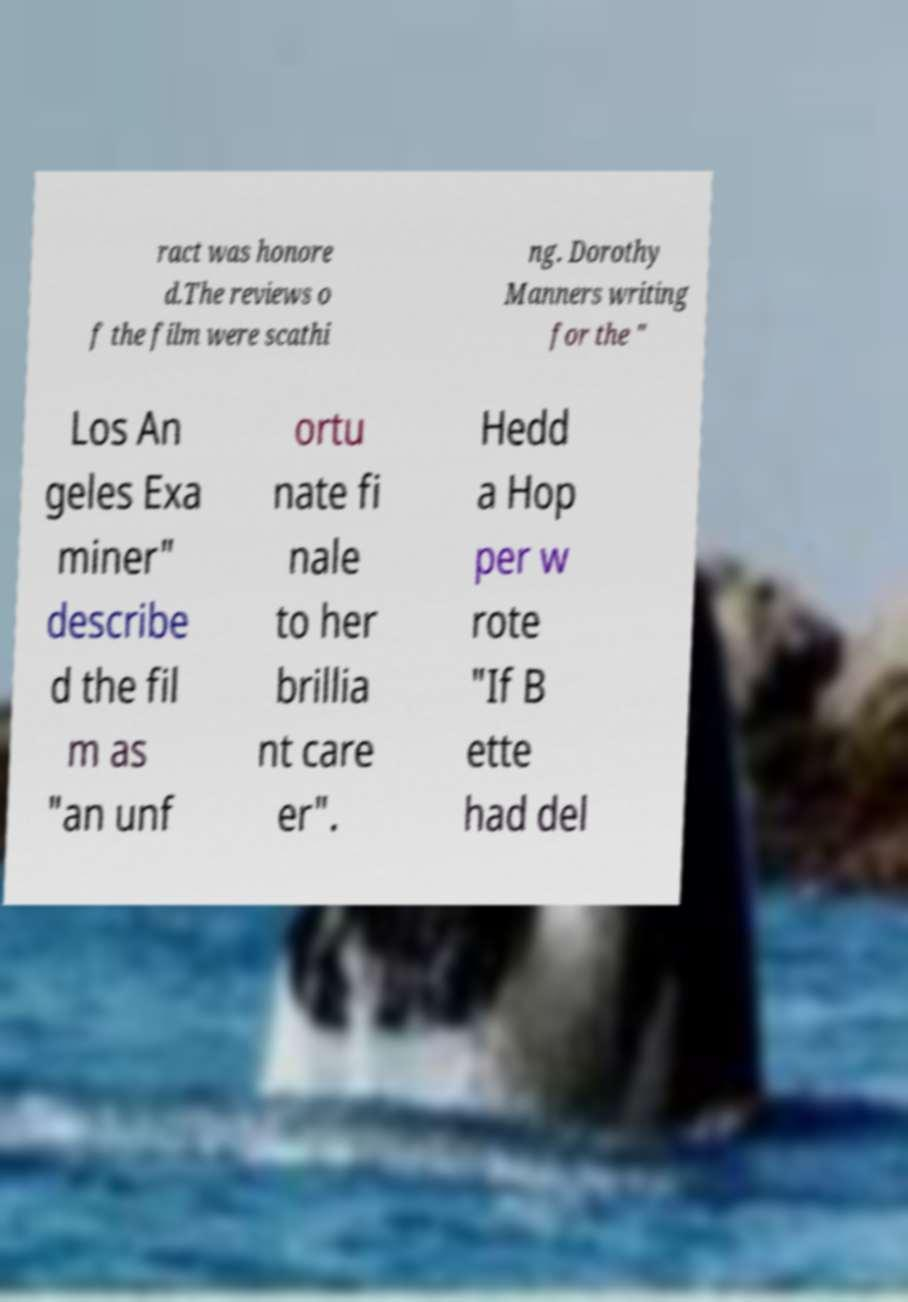Could you assist in decoding the text presented in this image and type it out clearly? ract was honore d.The reviews o f the film were scathi ng. Dorothy Manners writing for the " Los An geles Exa miner" describe d the fil m as "an unf ortu nate fi nale to her brillia nt care er". Hedd a Hop per w rote "If B ette had del 